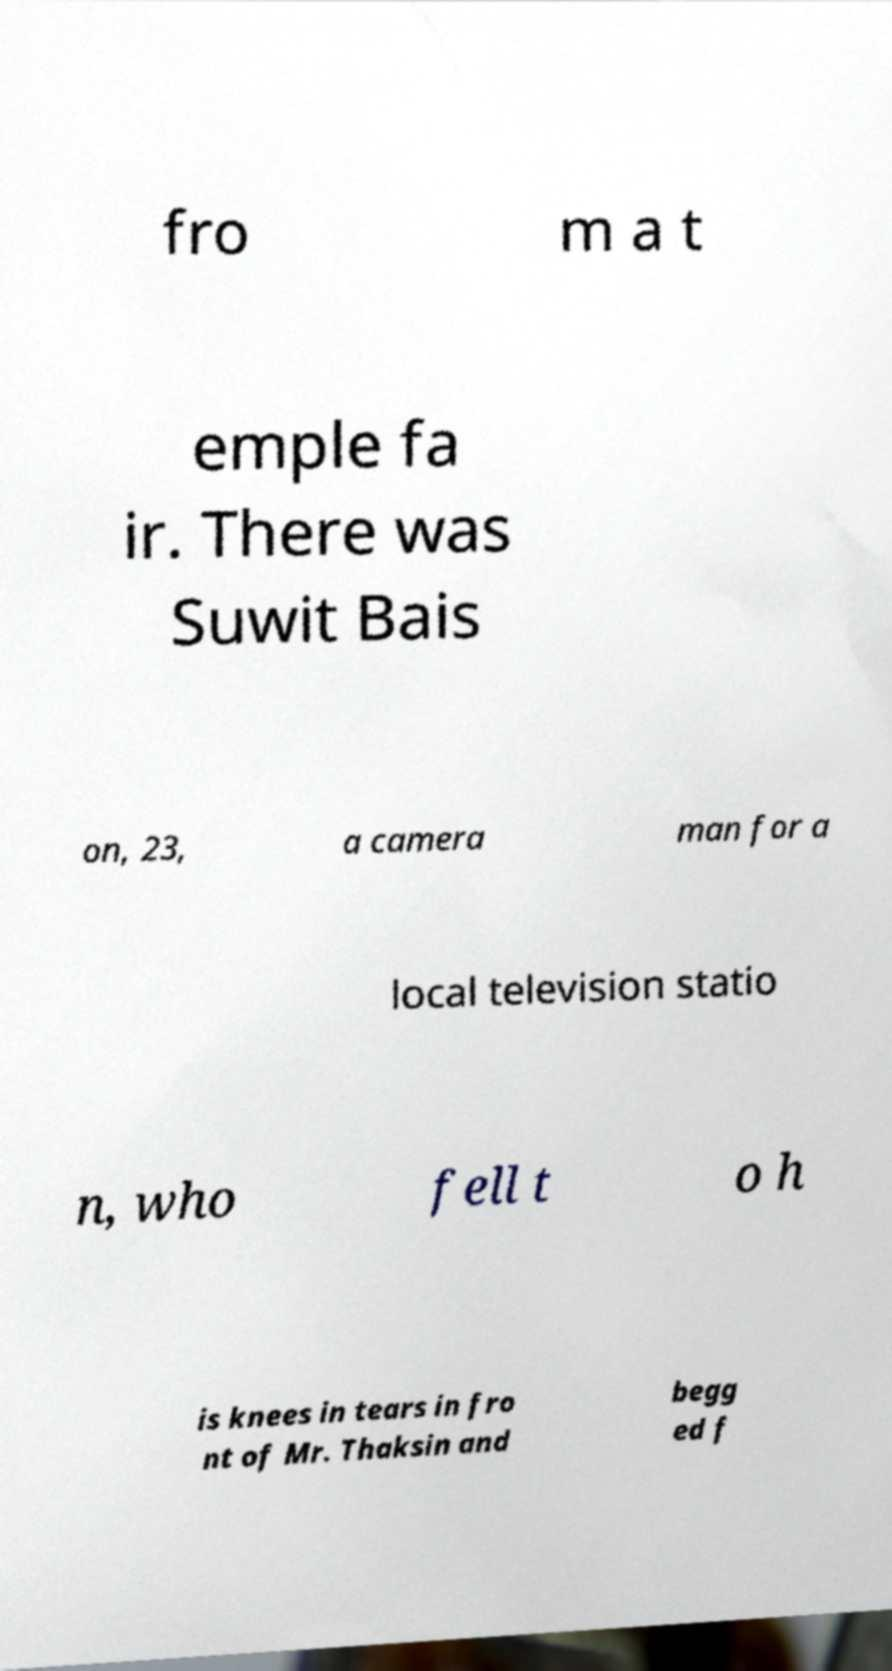Please read and relay the text visible in this image. What does it say? fro m a t emple fa ir. There was Suwit Bais on, 23, a camera man for a local television statio n, who fell t o h is knees in tears in fro nt of Mr. Thaksin and begg ed f 